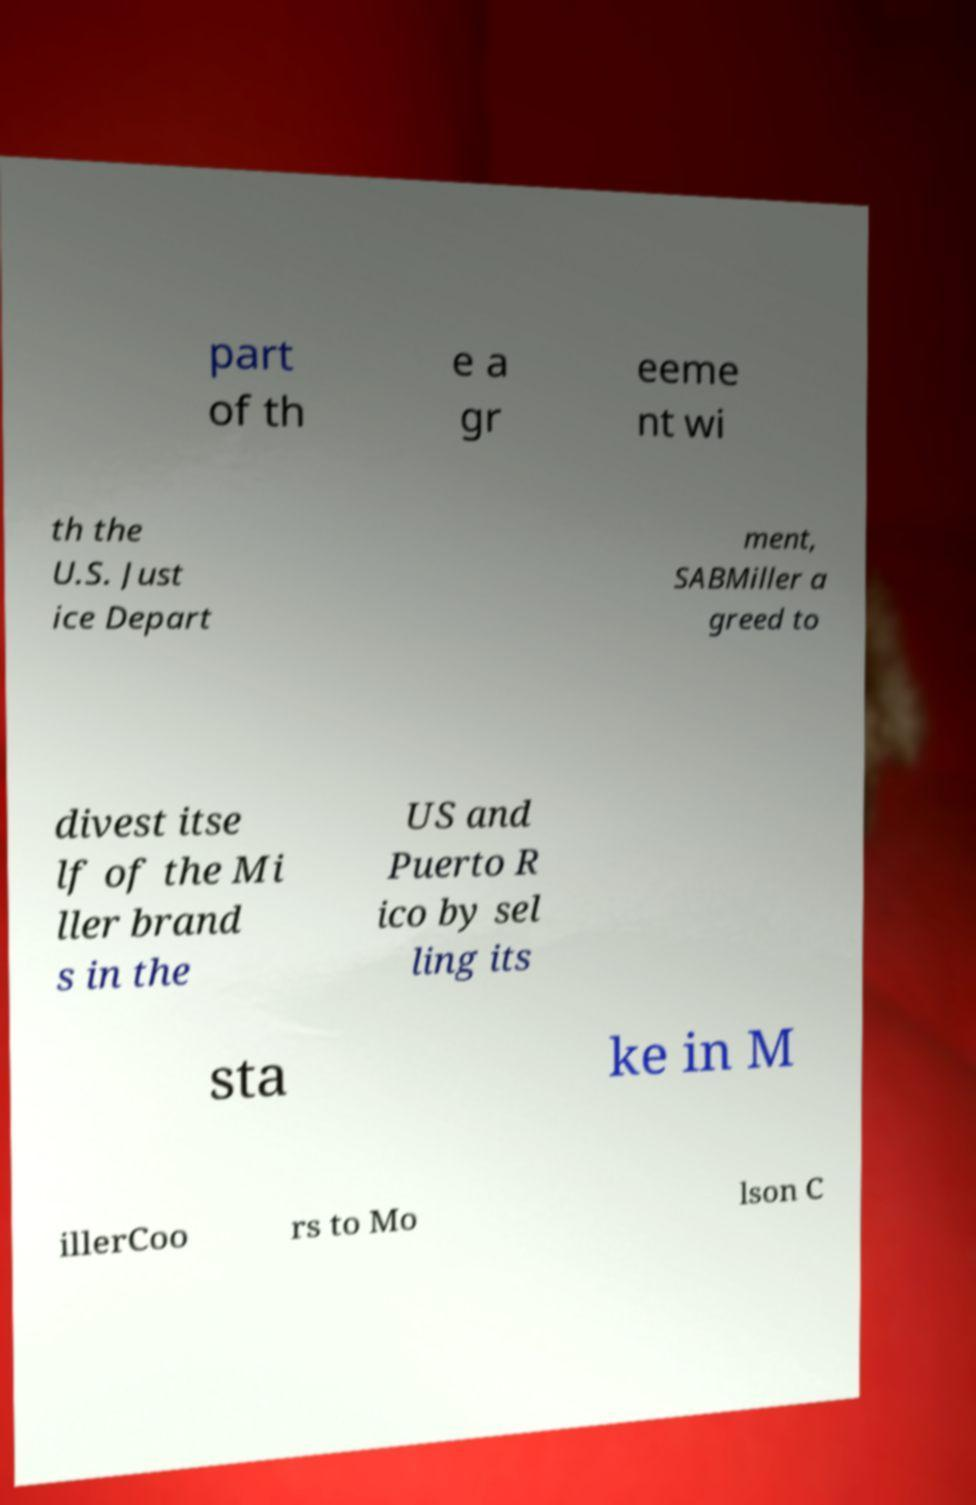Could you extract and type out the text from this image? part of th e a gr eeme nt wi th the U.S. Just ice Depart ment, SABMiller a greed to divest itse lf of the Mi ller brand s in the US and Puerto R ico by sel ling its sta ke in M illerCoo rs to Mo lson C 